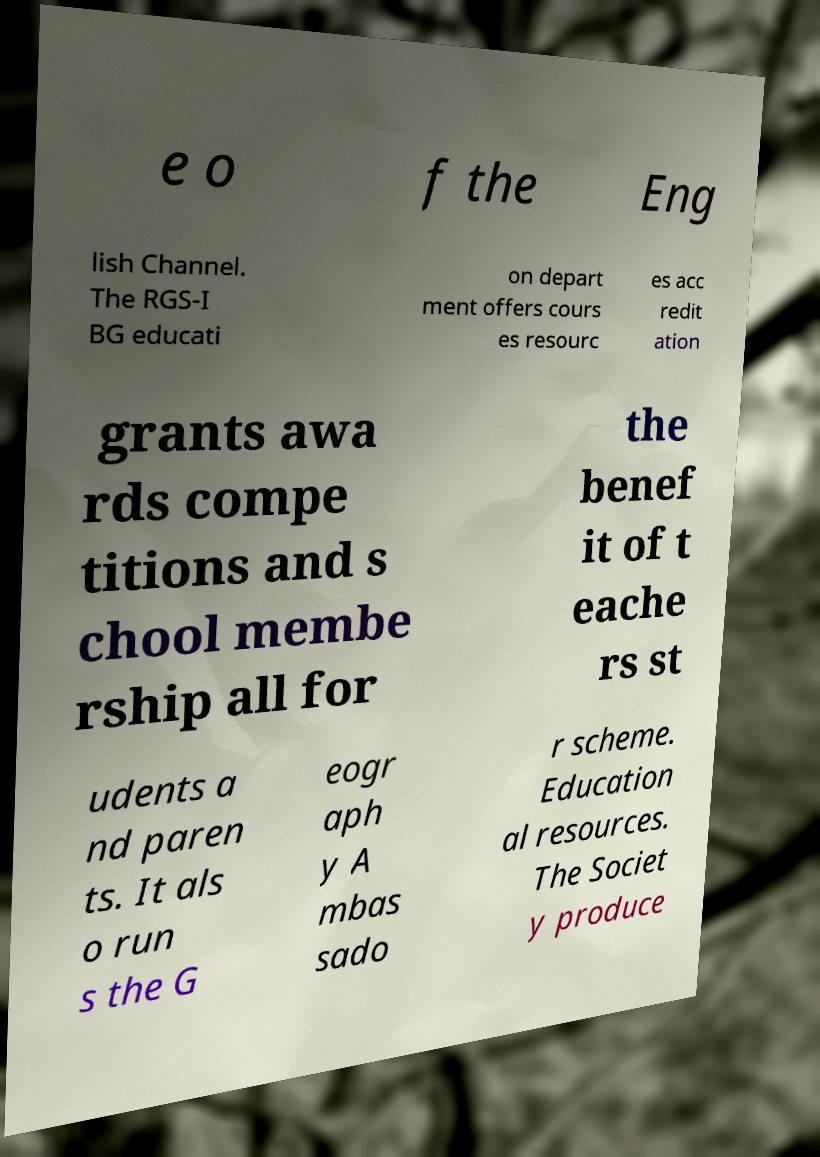I need the written content from this picture converted into text. Can you do that? e o f the Eng lish Channel. The RGS-I BG educati on depart ment offers cours es resourc es acc redit ation grants awa rds compe titions and s chool membe rship all for the benef it of t eache rs st udents a nd paren ts. It als o run s the G eogr aph y A mbas sado r scheme. Education al resources. The Societ y produce 